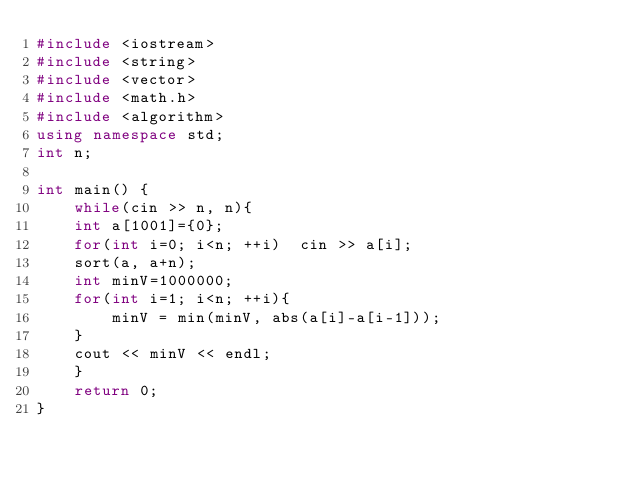Convert code to text. <code><loc_0><loc_0><loc_500><loc_500><_C++_>#include <iostream>
#include <string>
#include <vector>
#include <math.h>
#include <algorithm>
using namespace std;
int n;

int main() {
    while(cin >> n, n){
    int a[1001]={0};
    for(int i=0; i<n; ++i)  cin >> a[i];
    sort(a, a+n);
    int minV=1000000;
    for(int i=1; i<n; ++i){
        minV = min(minV, abs(a[i]-a[i-1]));
    }
    cout << minV << endl;
    }
    return 0;
}
</code> 